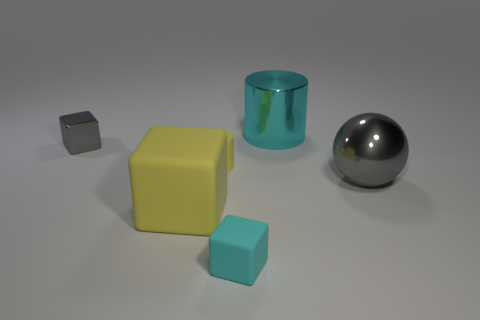Add 4 gray objects. How many objects exist? 10 Subtract all balls. How many objects are left? 5 Subtract 0 green cylinders. How many objects are left? 6 Subtract all purple matte spheres. Subtract all yellow matte blocks. How many objects are left? 5 Add 6 big cyan cylinders. How many big cyan cylinders are left? 7 Add 4 big cyan rubber objects. How many big cyan rubber objects exist? 4 